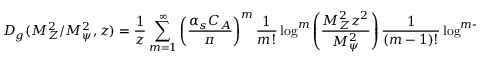<formula> <loc_0><loc_0><loc_500><loc_500>D _ { g } ( M _ { Z } ^ { 2 } / M _ { \psi } ^ { 2 } , z ) = \frac { 1 } { z } \sum _ { m = 1 } ^ { \infty } \left ( \frac { \alpha _ { s } C _ { A } } { \pi } \right ) ^ { m } \frac { 1 } m ! } \log ^ { m } \left ( \frac { M _ { Z } ^ { 2 } z ^ { 2 } } { M _ { \psi } ^ { 2 } } \right ) \frac { 1 } ( m - 1 ) ! } \log ^ { m - 1 } \left ( \frac { 1 } { z } \right ) .</formula> 